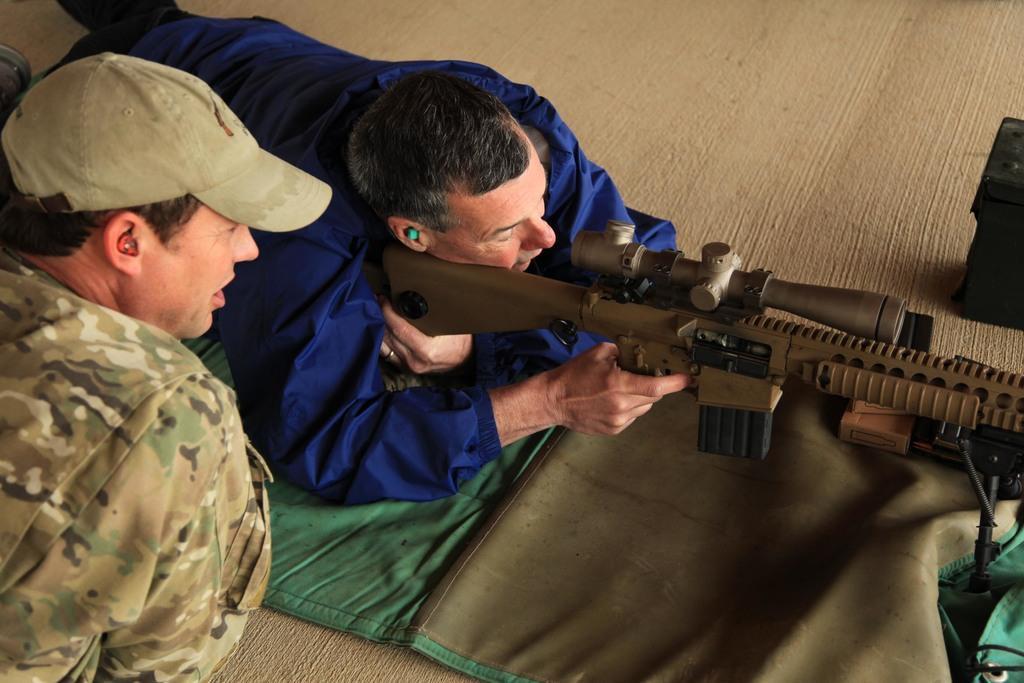Can you describe this image briefly? In this image we can see two men. One man is lying on the floor. He is wearing dark blue color shirt and black pant. He is holding weapon in his hand. At the bottom of the image green and brown color cloth sheet is there. The other man is wearing army uniform. 